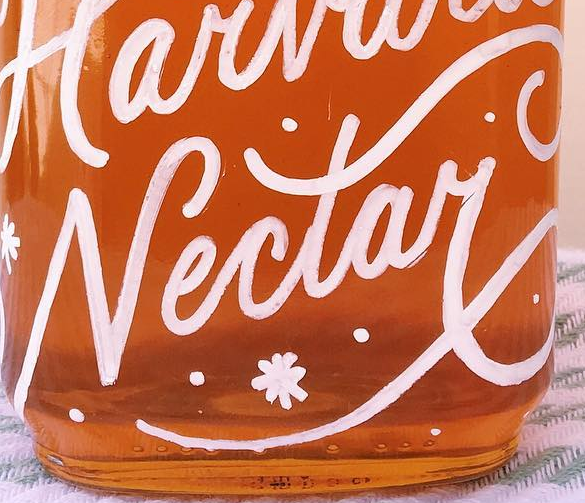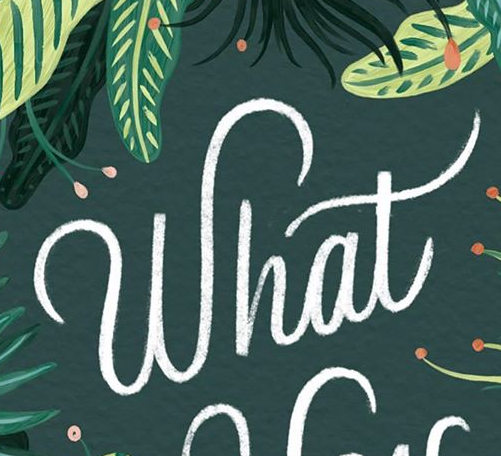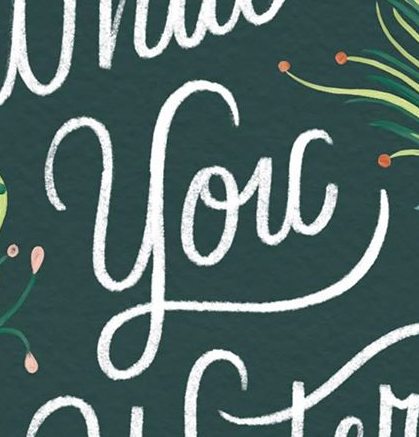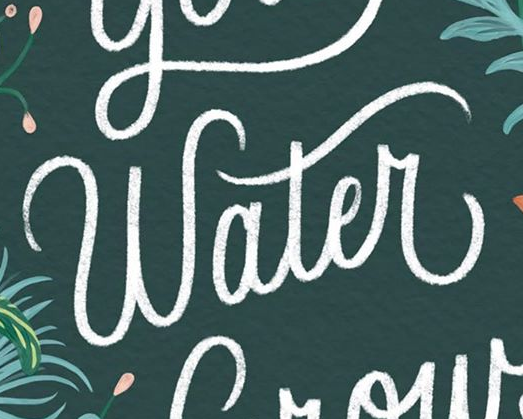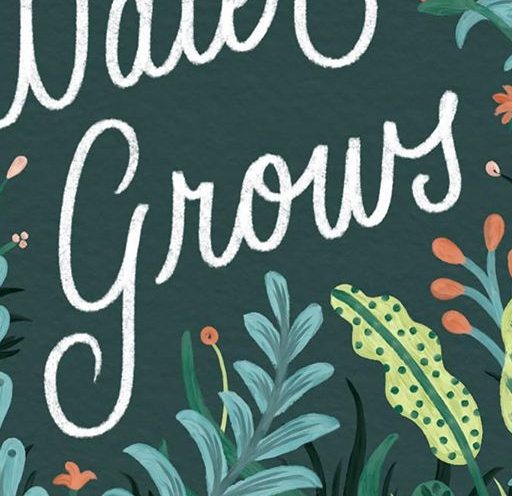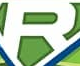What text appears in these images from left to right, separated by a semicolon? Nectay; What; You; Water; grows; R 